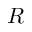<formula> <loc_0><loc_0><loc_500><loc_500>R</formula> 